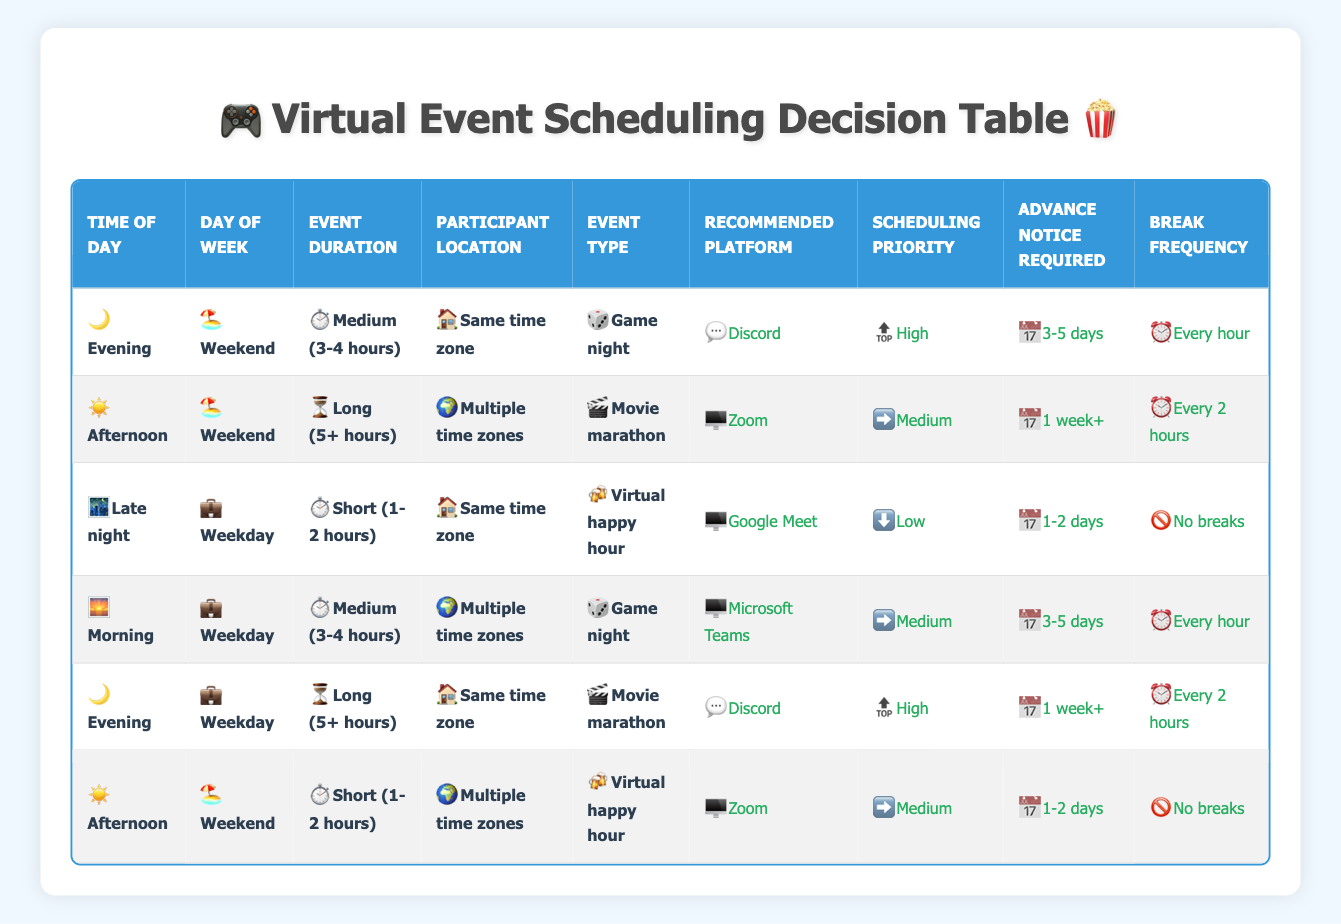What platforms are recommended for a medium-duration game night on a weekend evening with participants in the same time zone? In the table, you look for the row where the conditions match "Medium (3-4 hours)", "Weekend", "Evening", and "Same time zone". The row that meets these conditions suggests "Discord" as the recommended platform.
Answer: Discord Is the scheduling priority for a movie marathon on a weekend afternoon high, medium, or low? The relevant row for a "Movie marathon" during "Afternoon" on a "Weekend" shows a scheduling priority of "Medium".
Answer: Medium Do short virtual happy hours in the same time zone on weekdays require more than 2 days of advance notice? Referring to the row for "Virtual happy hour" that is "Short (1-2 hours)", "Weekday", and "Same time zone", the advance notice required is "1-2 days", which is less than 2 days. Therefore, the answer is "No".
Answer: No What is the recommended platform for a long movie marathon when participants are in multiple time zones? Check the row with the conditions "Long (5+ hours)", "Weekend", "Movie marathon", and "Multiple time zones". The correct platform listed is "Zoom" for this scenario.
Answer: Zoom If we hold a game night in the morning during weekdays with participants in multiple time zones, how often should breaks be scheduled? Find the row that represents a "Game night" during "Morning", "Weekday", and "Multiple time zones". It states that breaks should occur "Every hour", meaning breaks should be scheduled once every hour during the event.
Answer: Every hour What is the common action taken for a virtual happy hour that lasts for less than 2 hours on a weekday? The table indicates that for a "Virtual happy hour", "Short (1-2 hours)", "Weekday", and "Same time zone", the recommended platform is "Google Meet", and the scheduling priority is "Low". Thus, the answer is "Google Meet".
Answer: Google Meet Are breaks scheduled for a virtual happy hour in the afternoon on weekends? Looking at the conditions for an "Afternoon" "Virtual happy hour" on a "Weekend", it shows that breaks occur "No breaks", meaning that breaks are not scheduled for this event.
Answer: No What is the average duration for events scheduled on weekends? Events on weekends in the table include: "Medium (3-4 hours)" for Game night (1 instance), "Long (5+ hours)" for Movie marathon (1 instance), and "Short (1-2 hours)" for Virtual happy hour (1 instance). Summing the hours gives 4 + 5 + 1 = 10 hours for 3 events, which means the average duration is 10/3 ≈ 3.33 hours.
Answer: 3.33 hours For what type of event is "Discord" not the recommended platform based on the conditions presented in the table? Check for rows that do not list "Discord" as a recommended platform. The rows indicate that "Discord" is recommended for game nights and evening movie marathons. It is not recommended for the afternoon long movie marathon and the virtual happy hour. Thus, it’s noted that "Zoom" and "Google Meet" are platforms for those events instead.
Answer: Afternoon long movie marathon and virtual happy hour 